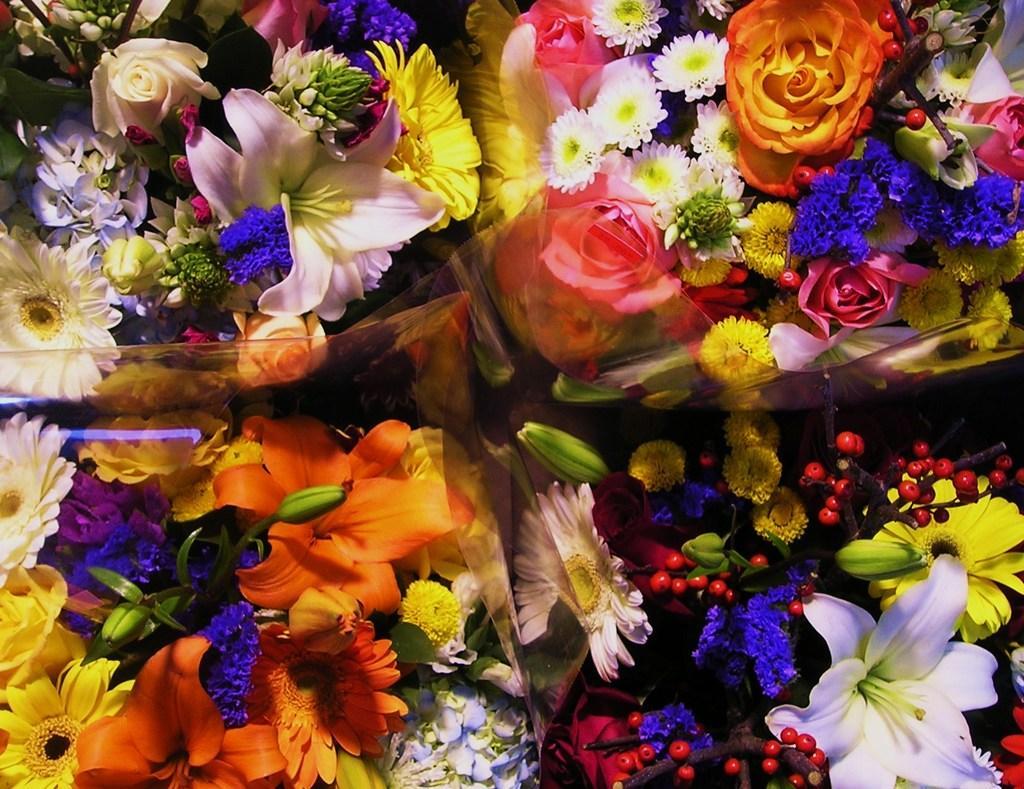How would you summarize this image in a sentence or two? In this image we can see some flowers and buds. 